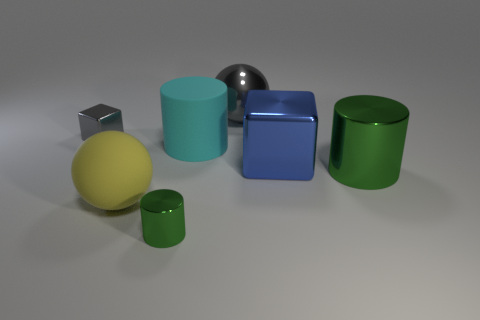Add 1 gray things. How many objects exist? 8 Subtract all cylinders. How many objects are left? 4 Add 5 gray metal spheres. How many gray metal spheres exist? 6 Subtract 1 yellow balls. How many objects are left? 6 Subtract all gray spheres. Subtract all small things. How many objects are left? 4 Add 7 gray metallic balls. How many gray metallic balls are left? 8 